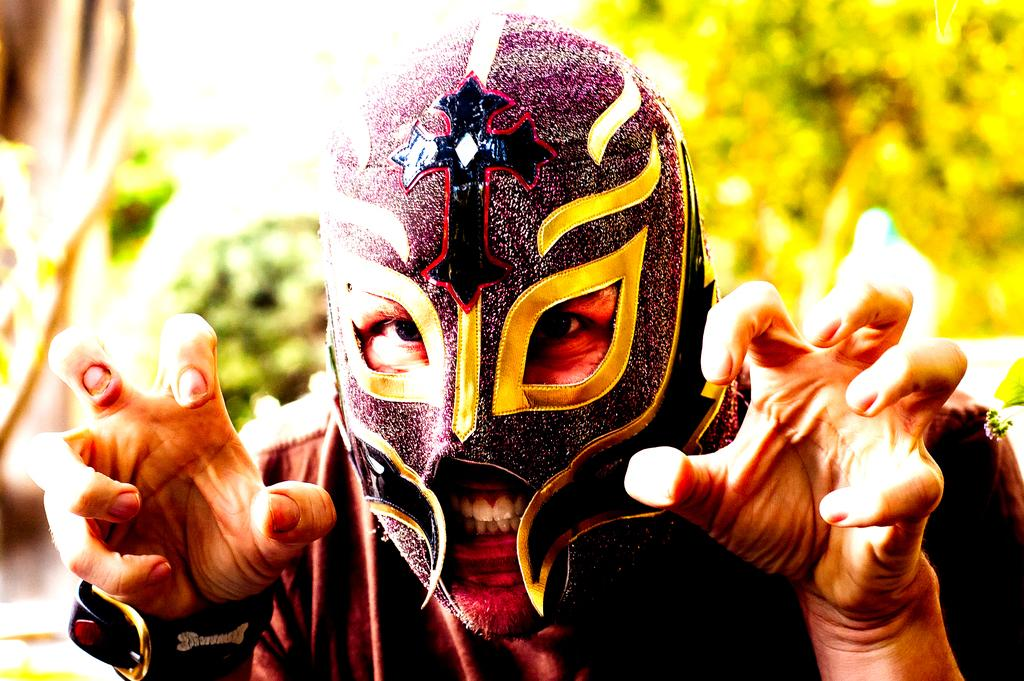What is present in the image? There is a person in the image. Can you describe the person's appearance? The person is wearing a mask. What can be seen in the background of the image? There is a tree visible behind the person. How many brothers does the person in the image have? There is no information about the person's brothers in the image, so it cannot be determined. 